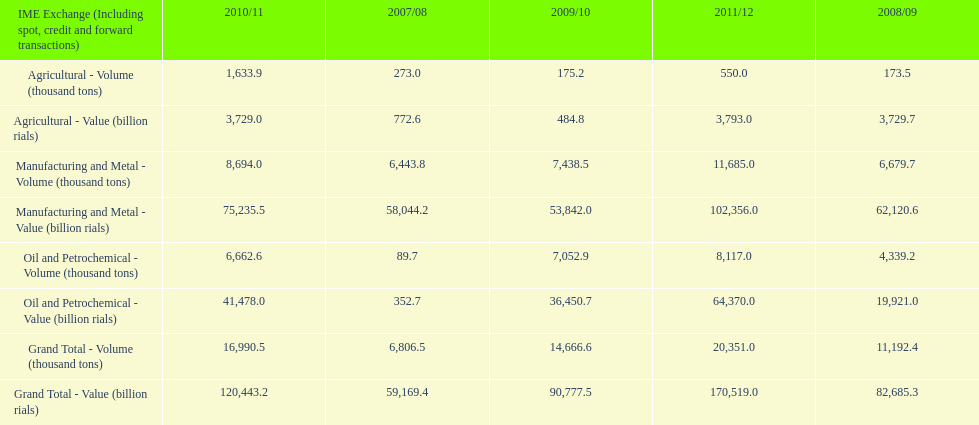Which year had the largest agricultural volume? 2010/11. 